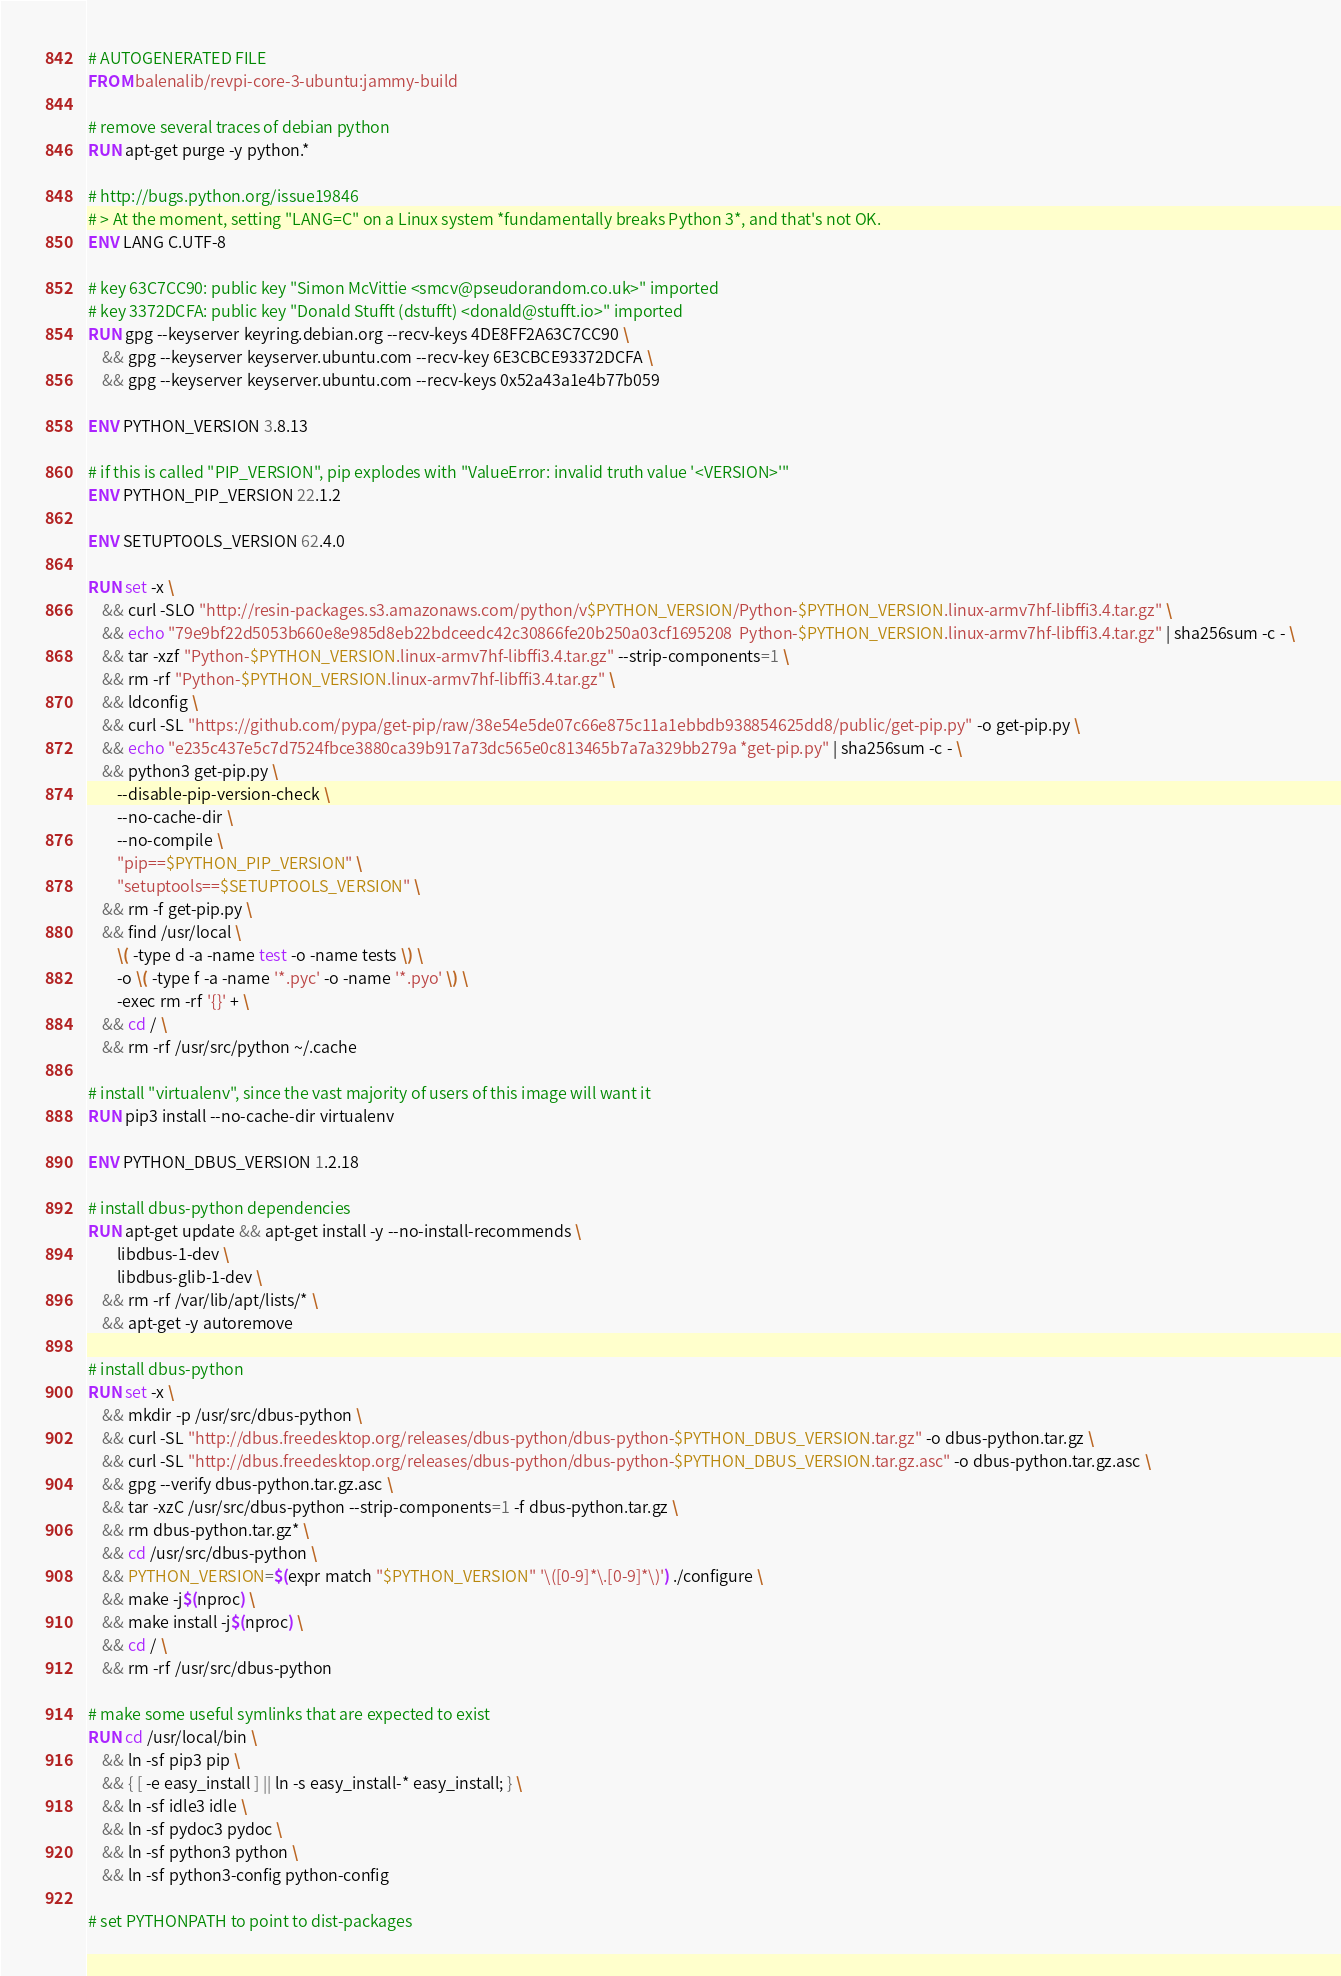<code> <loc_0><loc_0><loc_500><loc_500><_Dockerfile_># AUTOGENERATED FILE
FROM balenalib/revpi-core-3-ubuntu:jammy-build

# remove several traces of debian python
RUN apt-get purge -y python.*

# http://bugs.python.org/issue19846
# > At the moment, setting "LANG=C" on a Linux system *fundamentally breaks Python 3*, and that's not OK.
ENV LANG C.UTF-8

# key 63C7CC90: public key "Simon McVittie <smcv@pseudorandom.co.uk>" imported
# key 3372DCFA: public key "Donald Stufft (dstufft) <donald@stufft.io>" imported
RUN gpg --keyserver keyring.debian.org --recv-keys 4DE8FF2A63C7CC90 \
	&& gpg --keyserver keyserver.ubuntu.com --recv-key 6E3CBCE93372DCFA \
	&& gpg --keyserver keyserver.ubuntu.com --recv-keys 0x52a43a1e4b77b059

ENV PYTHON_VERSION 3.8.13

# if this is called "PIP_VERSION", pip explodes with "ValueError: invalid truth value '<VERSION>'"
ENV PYTHON_PIP_VERSION 22.1.2

ENV SETUPTOOLS_VERSION 62.4.0

RUN set -x \
	&& curl -SLO "http://resin-packages.s3.amazonaws.com/python/v$PYTHON_VERSION/Python-$PYTHON_VERSION.linux-armv7hf-libffi3.4.tar.gz" \
	&& echo "79e9bf22d5053b660e8e985d8eb22bdceedc42c30866fe20b250a03cf1695208  Python-$PYTHON_VERSION.linux-armv7hf-libffi3.4.tar.gz" | sha256sum -c - \
	&& tar -xzf "Python-$PYTHON_VERSION.linux-armv7hf-libffi3.4.tar.gz" --strip-components=1 \
	&& rm -rf "Python-$PYTHON_VERSION.linux-armv7hf-libffi3.4.tar.gz" \
	&& ldconfig \
	&& curl -SL "https://github.com/pypa/get-pip/raw/38e54e5de07c66e875c11a1ebbdb938854625dd8/public/get-pip.py" -o get-pip.py \
    && echo "e235c437e5c7d7524fbce3880ca39b917a73dc565e0c813465b7a7a329bb279a *get-pip.py" | sha256sum -c - \
    && python3 get-pip.py \
        --disable-pip-version-check \
        --no-cache-dir \
        --no-compile \
        "pip==$PYTHON_PIP_VERSION" \
        "setuptools==$SETUPTOOLS_VERSION" \
	&& rm -f get-pip.py \
	&& find /usr/local \
		\( -type d -a -name test -o -name tests \) \
		-o \( -type f -a -name '*.pyc' -o -name '*.pyo' \) \
		-exec rm -rf '{}' + \
	&& cd / \
	&& rm -rf /usr/src/python ~/.cache

# install "virtualenv", since the vast majority of users of this image will want it
RUN pip3 install --no-cache-dir virtualenv

ENV PYTHON_DBUS_VERSION 1.2.18

# install dbus-python dependencies 
RUN apt-get update && apt-get install -y --no-install-recommends \
		libdbus-1-dev \
		libdbus-glib-1-dev \
	&& rm -rf /var/lib/apt/lists/* \
	&& apt-get -y autoremove

# install dbus-python
RUN set -x \
	&& mkdir -p /usr/src/dbus-python \
	&& curl -SL "http://dbus.freedesktop.org/releases/dbus-python/dbus-python-$PYTHON_DBUS_VERSION.tar.gz" -o dbus-python.tar.gz \
	&& curl -SL "http://dbus.freedesktop.org/releases/dbus-python/dbus-python-$PYTHON_DBUS_VERSION.tar.gz.asc" -o dbus-python.tar.gz.asc \
	&& gpg --verify dbus-python.tar.gz.asc \
	&& tar -xzC /usr/src/dbus-python --strip-components=1 -f dbus-python.tar.gz \
	&& rm dbus-python.tar.gz* \
	&& cd /usr/src/dbus-python \
	&& PYTHON_VERSION=$(expr match "$PYTHON_VERSION" '\([0-9]*\.[0-9]*\)') ./configure \
	&& make -j$(nproc) \
	&& make install -j$(nproc) \
	&& cd / \
	&& rm -rf /usr/src/dbus-python

# make some useful symlinks that are expected to exist
RUN cd /usr/local/bin \
	&& ln -sf pip3 pip \
	&& { [ -e easy_install ] || ln -s easy_install-* easy_install; } \
	&& ln -sf idle3 idle \
	&& ln -sf pydoc3 pydoc \
	&& ln -sf python3 python \
	&& ln -sf python3-config python-config

# set PYTHONPATH to point to dist-packages</code> 